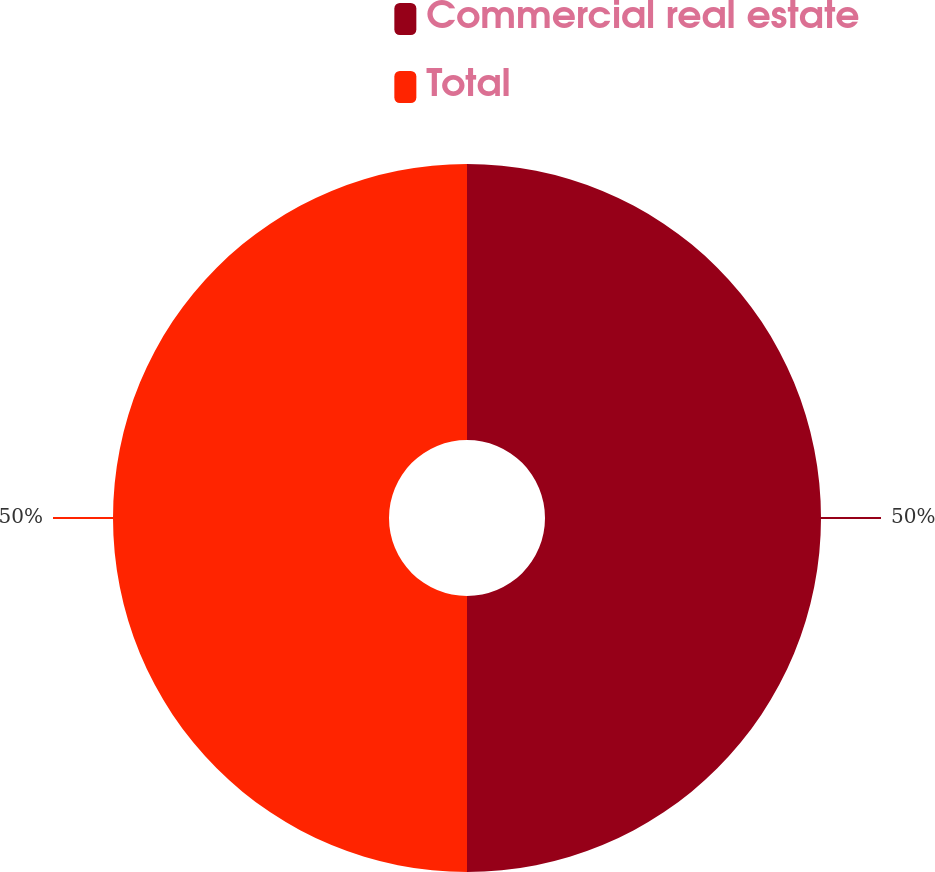Convert chart. <chart><loc_0><loc_0><loc_500><loc_500><pie_chart><fcel>Commercial real estate<fcel>Total<nl><fcel>50.0%<fcel>50.0%<nl></chart> 